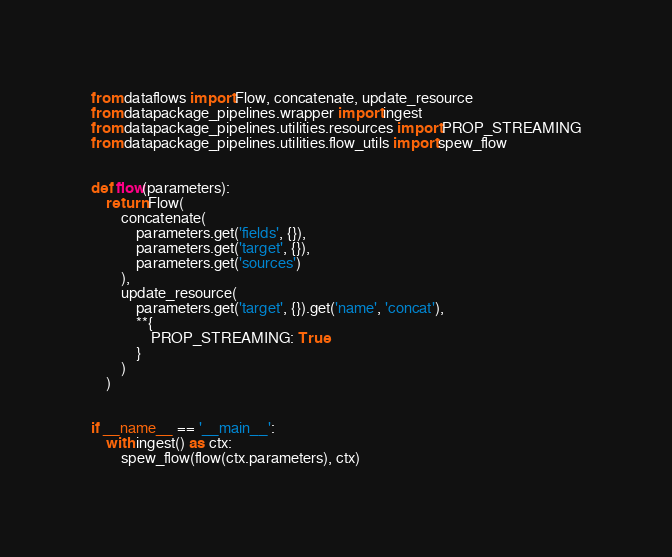<code> <loc_0><loc_0><loc_500><loc_500><_Python_>from dataflows import Flow, concatenate, update_resource
from datapackage_pipelines.wrapper import ingest
from datapackage_pipelines.utilities.resources import PROP_STREAMING
from datapackage_pipelines.utilities.flow_utils import spew_flow


def flow(parameters):
    return Flow(
        concatenate(
            parameters.get('fields', {}),
            parameters.get('target', {}),
            parameters.get('sources')
        ),
        update_resource(
            parameters.get('target', {}).get('name', 'concat'),
            **{
                PROP_STREAMING: True
            }
        )
    )


if __name__ == '__main__':
    with ingest() as ctx:
        spew_flow(flow(ctx.parameters), ctx)
</code> 